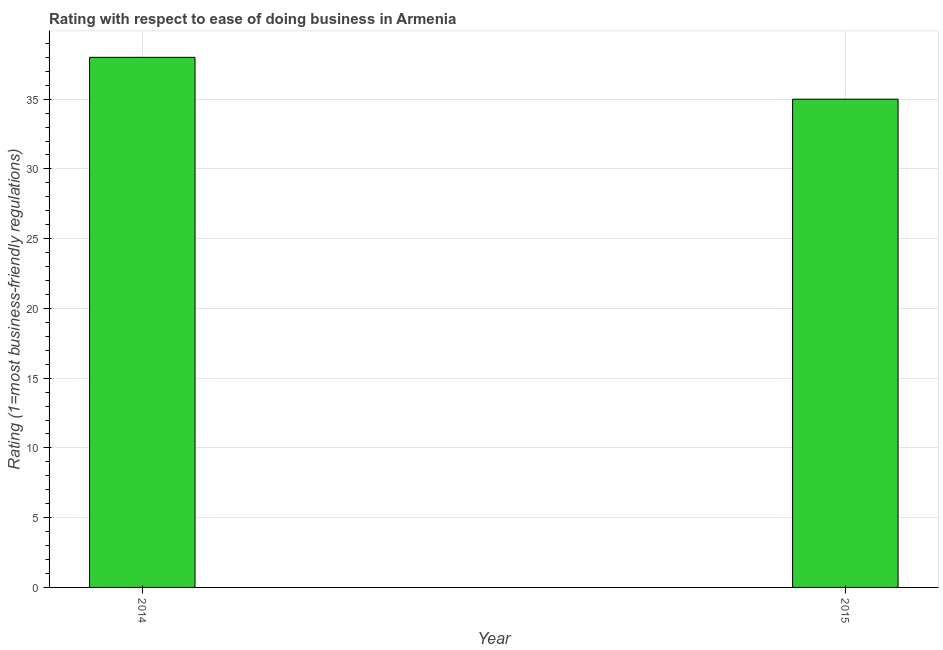Does the graph contain any zero values?
Ensure brevity in your answer.  No. What is the title of the graph?
Your answer should be very brief. Rating with respect to ease of doing business in Armenia. What is the label or title of the X-axis?
Make the answer very short. Year. What is the label or title of the Y-axis?
Give a very brief answer. Rating (1=most business-friendly regulations). What is the ease of doing business index in 2015?
Keep it short and to the point. 35. In which year was the ease of doing business index maximum?
Your answer should be very brief. 2014. In which year was the ease of doing business index minimum?
Ensure brevity in your answer.  2015. What is the average ease of doing business index per year?
Your answer should be very brief. 36. What is the median ease of doing business index?
Make the answer very short. 36.5. What is the ratio of the ease of doing business index in 2014 to that in 2015?
Your answer should be compact. 1.09. How many bars are there?
Keep it short and to the point. 2. Are all the bars in the graph horizontal?
Keep it short and to the point. No. What is the difference between two consecutive major ticks on the Y-axis?
Ensure brevity in your answer.  5. Are the values on the major ticks of Y-axis written in scientific E-notation?
Your answer should be compact. No. What is the Rating (1=most business-friendly regulations) of 2014?
Provide a short and direct response. 38. What is the ratio of the Rating (1=most business-friendly regulations) in 2014 to that in 2015?
Keep it short and to the point. 1.09. 